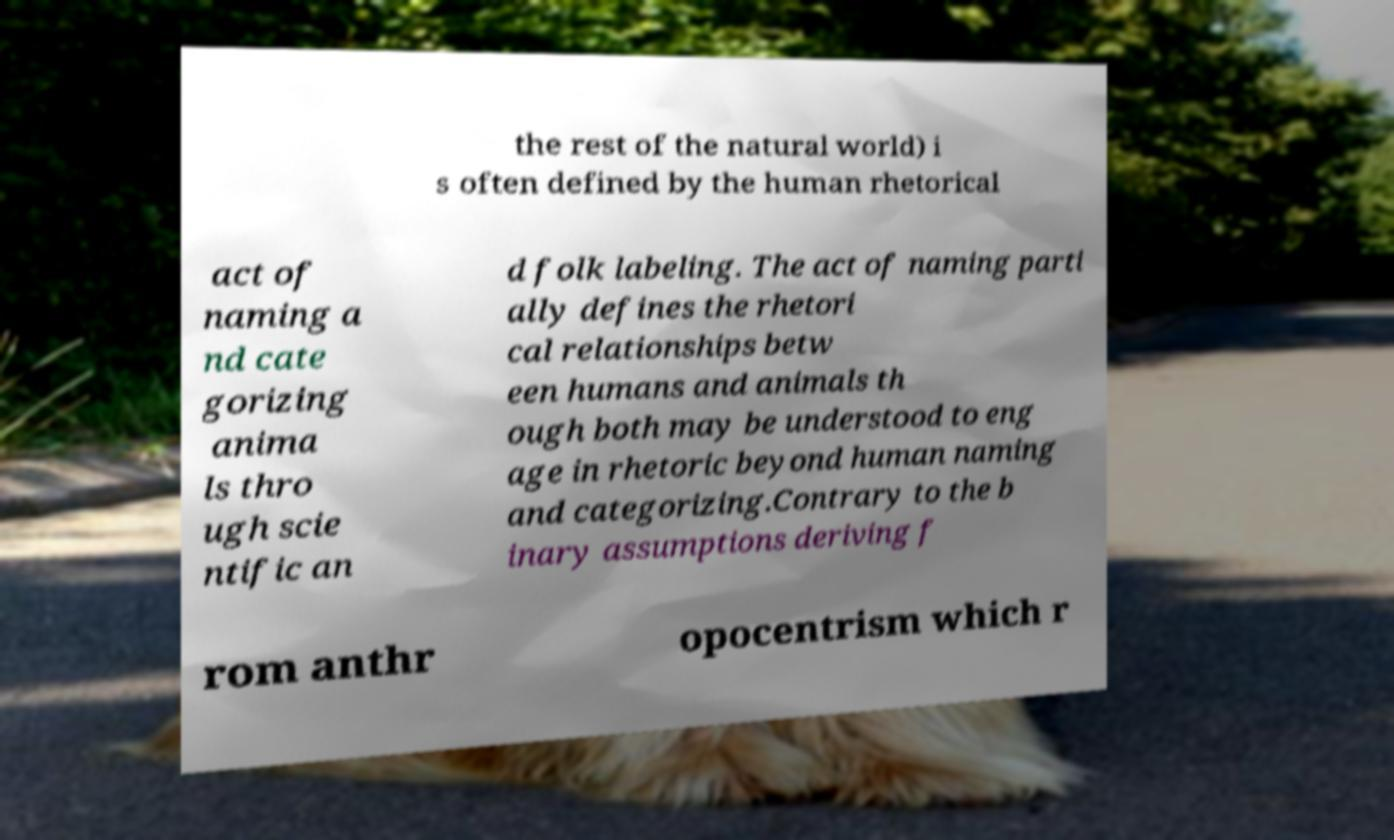Can you accurately transcribe the text from the provided image for me? the rest of the natural world) i s often defined by the human rhetorical act of naming a nd cate gorizing anima ls thro ugh scie ntific an d folk labeling. The act of naming parti ally defines the rhetori cal relationships betw een humans and animals th ough both may be understood to eng age in rhetoric beyond human naming and categorizing.Contrary to the b inary assumptions deriving f rom anthr opocentrism which r 